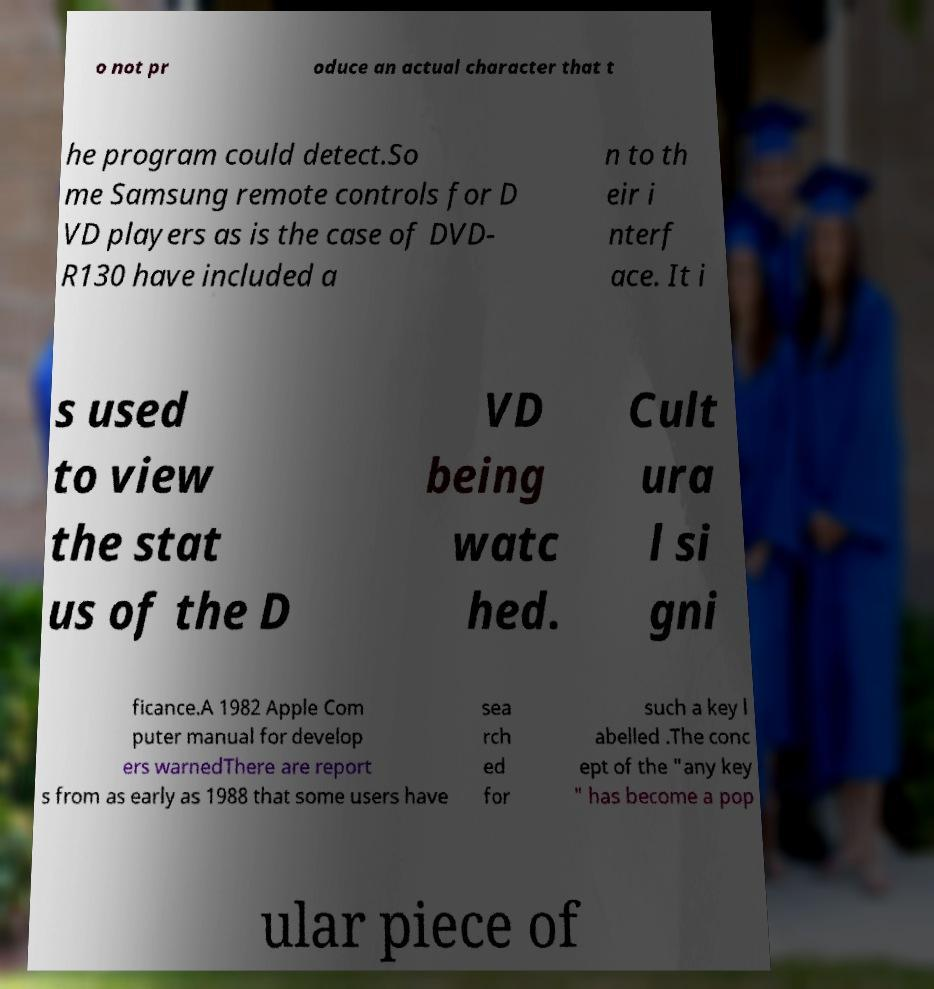Please identify and transcribe the text found in this image. o not pr oduce an actual character that t he program could detect.So me Samsung remote controls for D VD players as is the case of DVD- R130 have included a n to th eir i nterf ace. It i s used to view the stat us of the D VD being watc hed. Cult ura l si gni ficance.A 1982 Apple Com puter manual for develop ers warnedThere are report s from as early as 1988 that some users have sea rch ed for such a key l abelled .The conc ept of the "any key " has become a pop ular piece of 